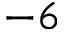<formula> <loc_0><loc_0><loc_500><loc_500>- 6</formula> 